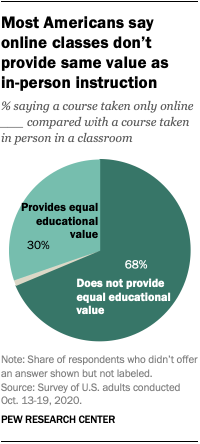Give some essential details in this illustration. The majority of Americans believe that online classes provide equal educational value to in-person classes. According to a survey, 0.3% of Americans believe that online classes provide equal educational value as traditional classes. 